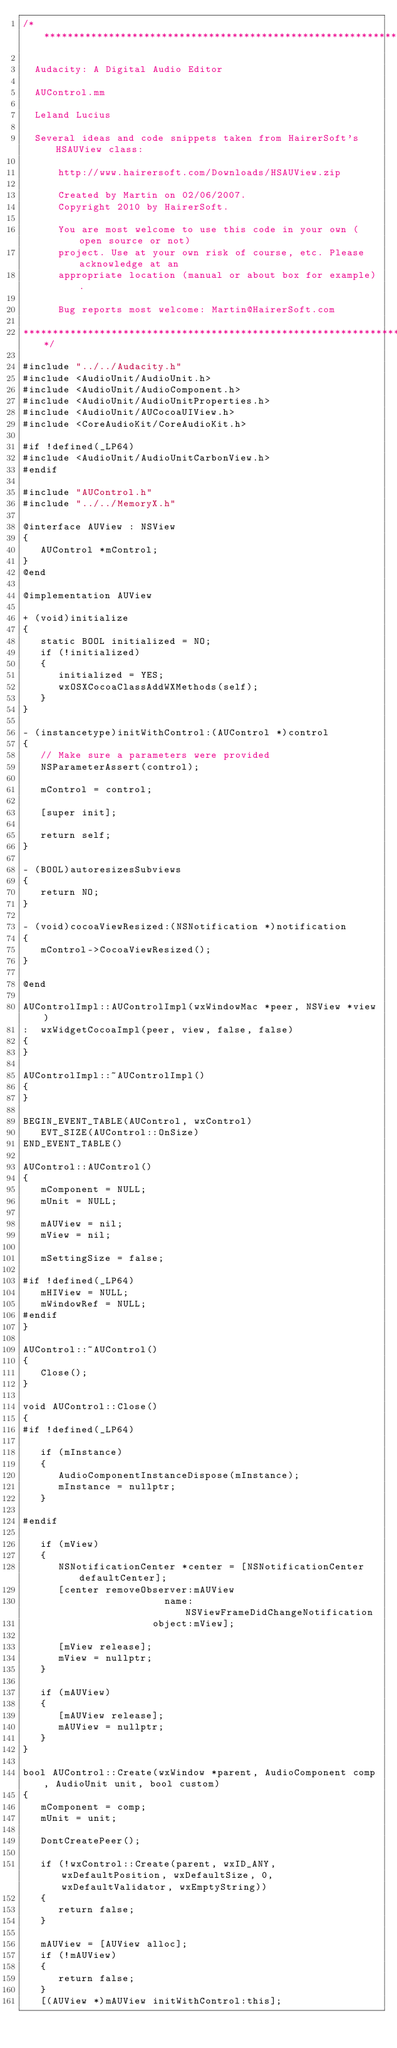Convert code to text. <code><loc_0><loc_0><loc_500><loc_500><_ObjectiveC_>/**********************************************************************

  Audacity: A Digital Audio Editor

  AUControl.mm

  Leland Lucius

  Several ideas and code snippets taken from HairerSoft's HSAUView class:

      http://www.hairersoft.com/Downloads/HSAUView.zip

      Created by Martin on 02/06/2007.
      Copyright 2010 by HairerSoft.
      
      You are most welcome to use this code in your own (open source or not)
      project. Use at your own risk of course, etc. Please acknowledge at an
      appropriate location (manual or about box for example).
      
      Bug reports most welcome: Martin@HairerSoft.com
      
**********************************************************************/

#include "../../Audacity.h"
#include <AudioUnit/AudioUnit.h>
#include <AudioUnit/AudioComponent.h>
#include <AudioUnit/AudioUnitProperties.h>
#include <AudioUnit/AUCocoaUIView.h>
#include <CoreAudioKit/CoreAudioKit.h>

#if !defined(_LP64)
#include <AudioUnit/AudioUnitCarbonView.h>
#endif

#include "AUControl.h"
#include "../../MemoryX.h"

@interface AUView : NSView
{
   AUControl *mControl;
}
@end

@implementation AUView
 
+ (void)initialize
{
   static BOOL initialized = NO;
   if (!initialized)
   {
      initialized = YES;
      wxOSXCocoaClassAddWXMethods(self);
   }
}

- (instancetype)initWithControl:(AUControl *)control
{
   // Make sure a parameters were provided
   NSParameterAssert(control);

   mControl = control;

   [super init];

   return self;
}

- (BOOL)autoresizesSubviews
{
   return NO;
}

- (void)cocoaViewResized:(NSNotification *)notification
{
   mControl->CocoaViewResized();
}

@end

AUControlImpl::AUControlImpl(wxWindowMac *peer, NSView *view)
:  wxWidgetCocoaImpl(peer, view, false, false)
{
}

AUControlImpl::~AUControlImpl()
{
}

BEGIN_EVENT_TABLE(AUControl, wxControl)
   EVT_SIZE(AUControl::OnSize)
END_EVENT_TABLE()

AUControl::AUControl()
{
   mComponent = NULL;
   mUnit = NULL;

   mAUView = nil;
   mView = nil;

   mSettingSize = false;

#if !defined(_LP64)
   mHIView = NULL;
   mWindowRef = NULL;
#endif
}

AUControl::~AUControl()
{
   Close();
}

void AUControl::Close()
{
#if !defined(_LP64)

   if (mInstance)
   {
      AudioComponentInstanceDispose(mInstance);
      mInstance = nullptr;
   }

#endif

   if (mView)
   {
      NSNotificationCenter *center = [NSNotificationCenter defaultCenter];
      [center removeObserver:mAUView
                        name:NSViewFrameDidChangeNotification
                      object:mView];

      [mView release];
      mView = nullptr;
   }

   if (mAUView)
   {
      [mAUView release];
      mAUView = nullptr;
   }
}

bool AUControl::Create(wxWindow *parent, AudioComponent comp, AudioUnit unit, bool custom)
{
   mComponent = comp;
   mUnit = unit;

   DontCreatePeer();

   if (!wxControl::Create(parent, wxID_ANY, wxDefaultPosition, wxDefaultSize, 0, wxDefaultValidator, wxEmptyString))
   {
      return false;
   }

   mAUView = [AUView alloc];
   if (!mAUView)
   {
      return false;
   }
   [(AUView *)mAUView initWithControl:this];</code> 